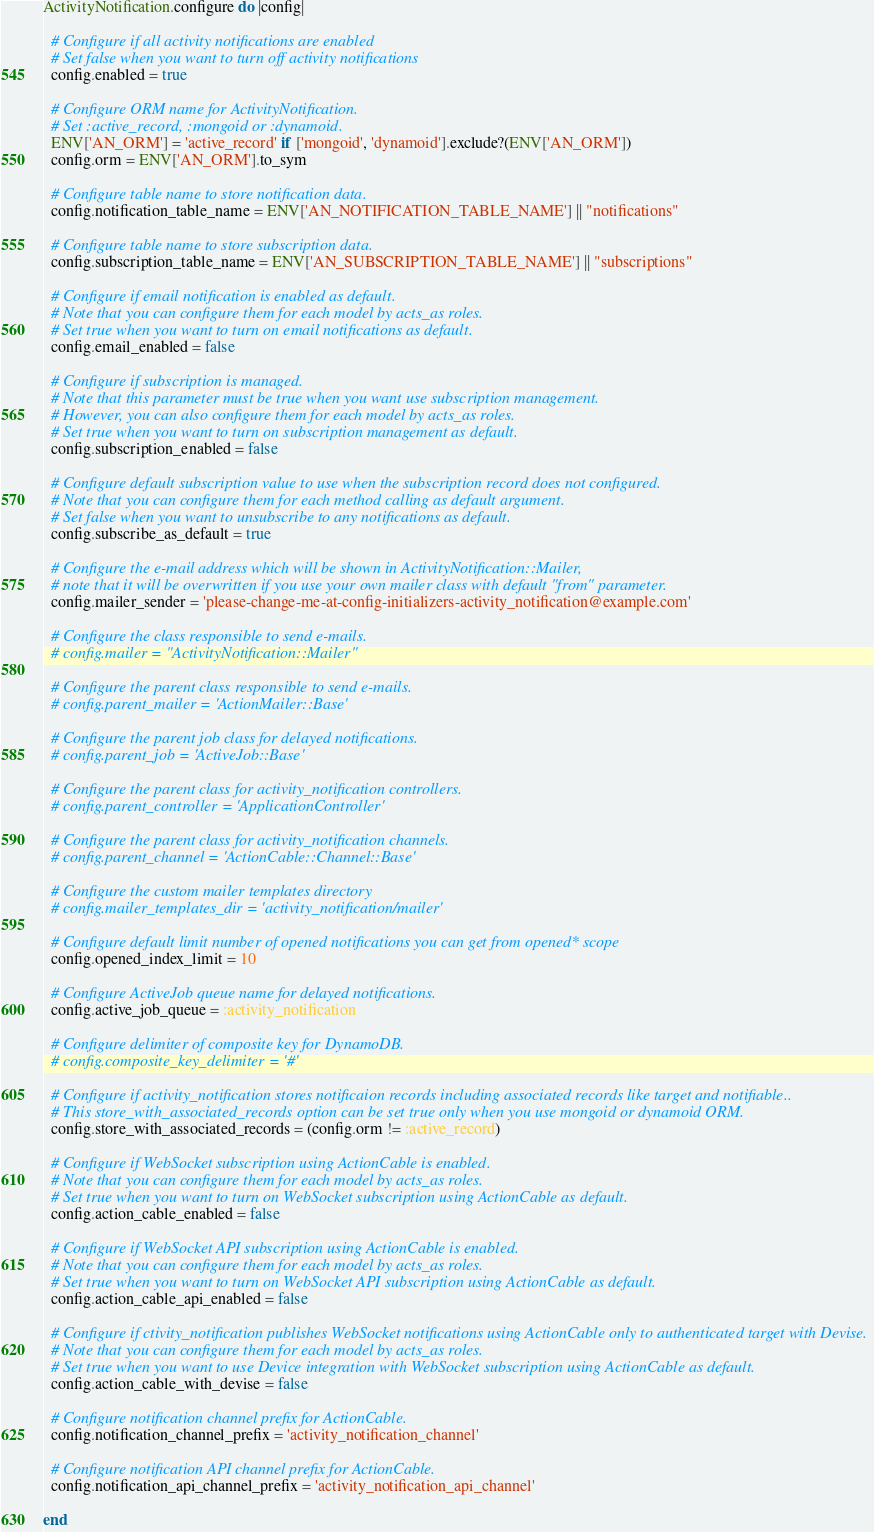Convert code to text. <code><loc_0><loc_0><loc_500><loc_500><_Ruby_>ActivityNotification.configure do |config|

  # Configure if all activity notifications are enabled
  # Set false when you want to turn off activity notifications
  config.enabled = true

  # Configure ORM name for ActivityNotification.
  # Set :active_record, :mongoid or :dynamoid.
  ENV['AN_ORM'] = 'active_record' if ['mongoid', 'dynamoid'].exclude?(ENV['AN_ORM'])
  config.orm = ENV['AN_ORM'].to_sym

  # Configure table name to store notification data.
  config.notification_table_name = ENV['AN_NOTIFICATION_TABLE_NAME'] || "notifications"

  # Configure table name to store subscription data.
  config.subscription_table_name = ENV['AN_SUBSCRIPTION_TABLE_NAME'] || "subscriptions"

  # Configure if email notification is enabled as default.
  # Note that you can configure them for each model by acts_as roles.
  # Set true when you want to turn on email notifications as default.
  config.email_enabled = false

  # Configure if subscription is managed.
  # Note that this parameter must be true when you want use subscription management.
  # However, you can also configure them for each model by acts_as roles.
  # Set true when you want to turn on subscription management as default.
  config.subscription_enabled = false

  # Configure default subscription value to use when the subscription record does not configured.
  # Note that you can configure them for each method calling as default argument.
  # Set false when you want to unsubscribe to any notifications as default.
  config.subscribe_as_default = true

  # Configure the e-mail address which will be shown in ActivityNotification::Mailer,
  # note that it will be overwritten if you use your own mailer class with default "from" parameter.
  config.mailer_sender = 'please-change-me-at-config-initializers-activity_notification@example.com'

  # Configure the class responsible to send e-mails.
  # config.mailer = "ActivityNotification::Mailer"

  # Configure the parent class responsible to send e-mails.
  # config.parent_mailer = 'ActionMailer::Base'

  # Configure the parent job class for delayed notifications.
  # config.parent_job = 'ActiveJob::Base'

  # Configure the parent class for activity_notification controllers.
  # config.parent_controller = 'ApplicationController'

  # Configure the parent class for activity_notification channels.
  # config.parent_channel = 'ActionCable::Channel::Base'

  # Configure the custom mailer templates directory
  # config.mailer_templates_dir = 'activity_notification/mailer'

  # Configure default limit number of opened notifications you can get from opened* scope
  config.opened_index_limit = 10

  # Configure ActiveJob queue name for delayed notifications.
  config.active_job_queue = :activity_notification

  # Configure delimiter of composite key for DynamoDB.
  # config.composite_key_delimiter = '#'

  # Configure if activity_notification stores notificaion records including associated records like target and notifiable..
  # This store_with_associated_records option can be set true only when you use mongoid or dynamoid ORM.
  config.store_with_associated_records = (config.orm != :active_record)

  # Configure if WebSocket subscription using ActionCable is enabled.
  # Note that you can configure them for each model by acts_as roles.
  # Set true when you want to turn on WebSocket subscription using ActionCable as default.
  config.action_cable_enabled = false

  # Configure if WebSocket API subscription using ActionCable is enabled.
  # Note that you can configure them for each model by acts_as roles.
  # Set true when you want to turn on WebSocket API subscription using ActionCable as default.
  config.action_cable_api_enabled = false

  # Configure if ctivity_notification publishes WebSocket notifications using ActionCable only to authenticated target with Devise.
  # Note that you can configure them for each model by acts_as roles.
  # Set true when you want to use Device integration with WebSocket subscription using ActionCable as default.
  config.action_cable_with_devise = false

  # Configure notification channel prefix for ActionCable.
  config.notification_channel_prefix = 'activity_notification_channel'

  # Configure notification API channel prefix for ActionCable.
  config.notification_api_channel_prefix = 'activity_notification_api_channel'

end
</code> 